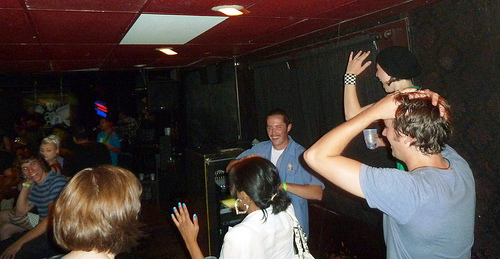<image>
Is there a man on the woman? No. The man is not positioned on the woman. They may be near each other, but the man is not supported by or resting on top of the woman. Is there a man under the hands? No. The man is not positioned under the hands. The vertical relationship between these objects is different. 